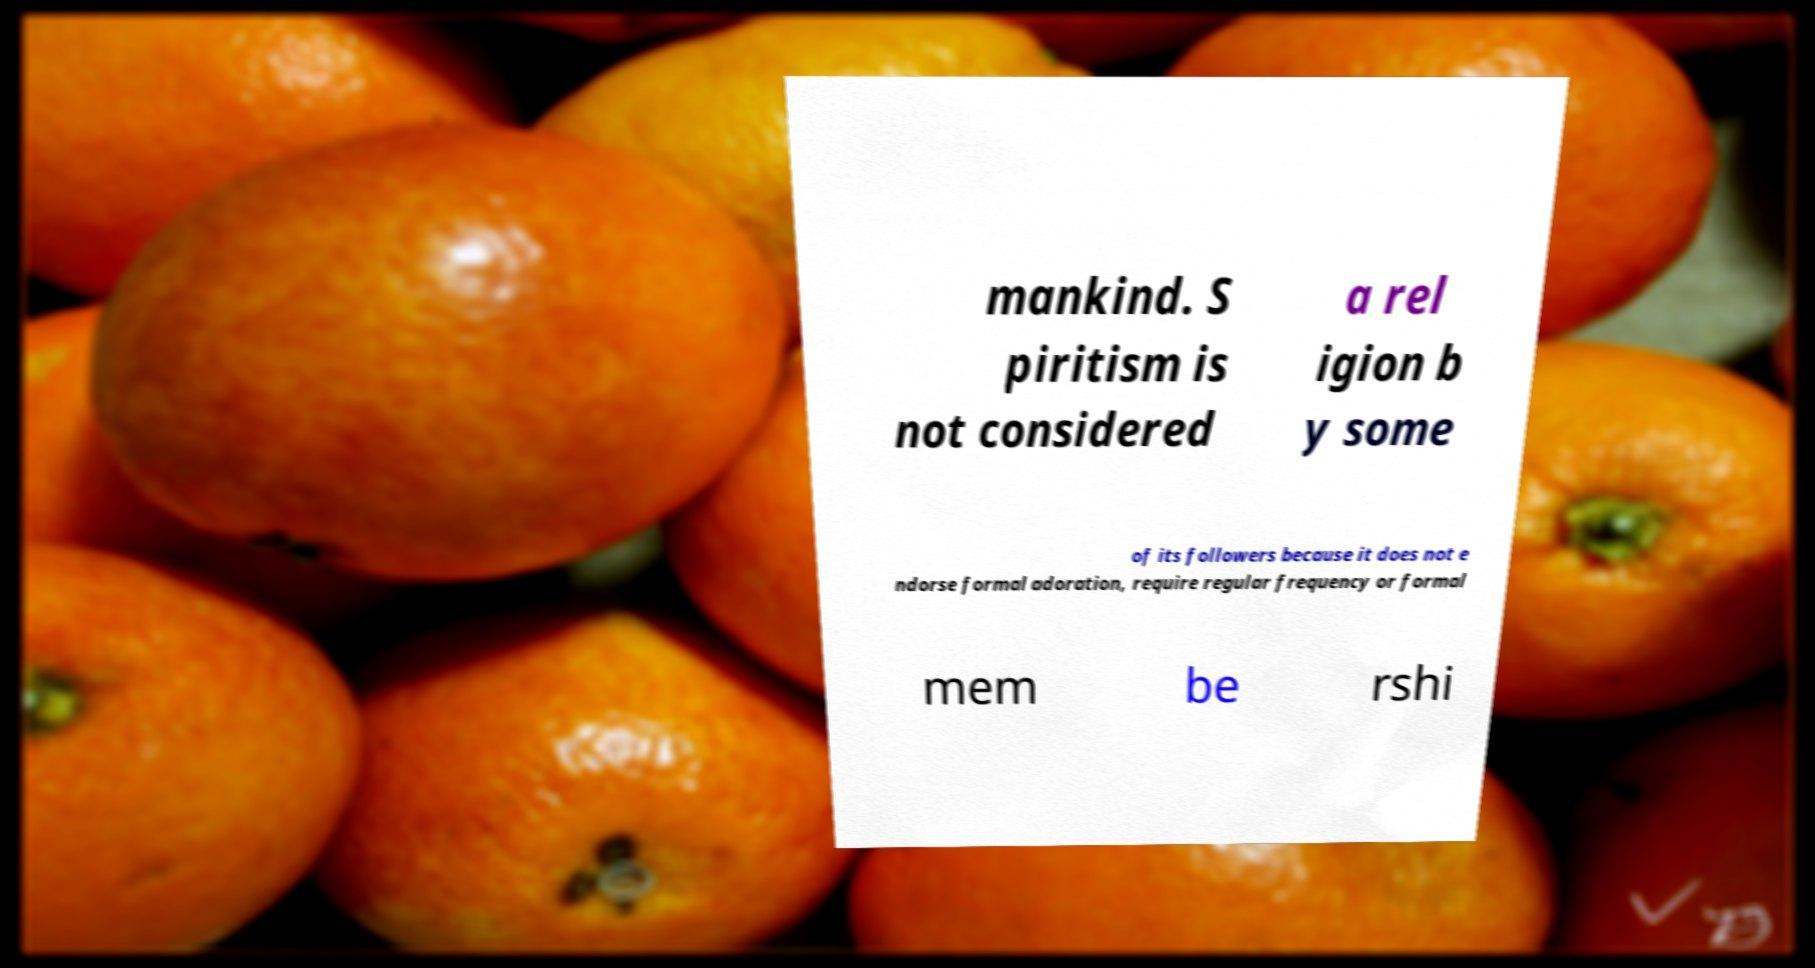Could you extract and type out the text from this image? mankind. S piritism is not considered a rel igion b y some of its followers because it does not e ndorse formal adoration, require regular frequency or formal mem be rshi 